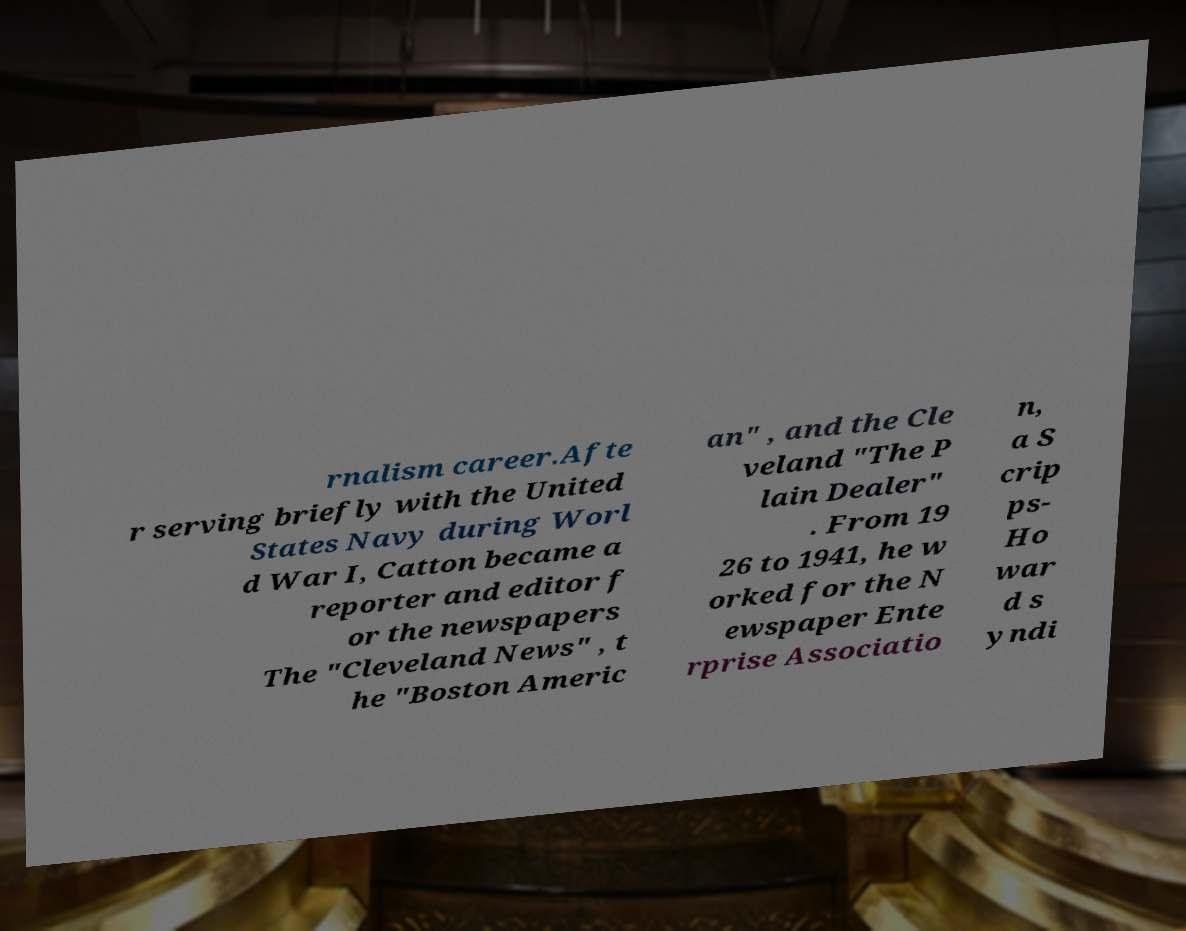What messages or text are displayed in this image? I need them in a readable, typed format. rnalism career.Afte r serving briefly with the United States Navy during Worl d War I, Catton became a reporter and editor f or the newspapers The "Cleveland News" , t he "Boston Americ an" , and the Cle veland "The P lain Dealer" . From 19 26 to 1941, he w orked for the N ewspaper Ente rprise Associatio n, a S crip ps- Ho war d s yndi 